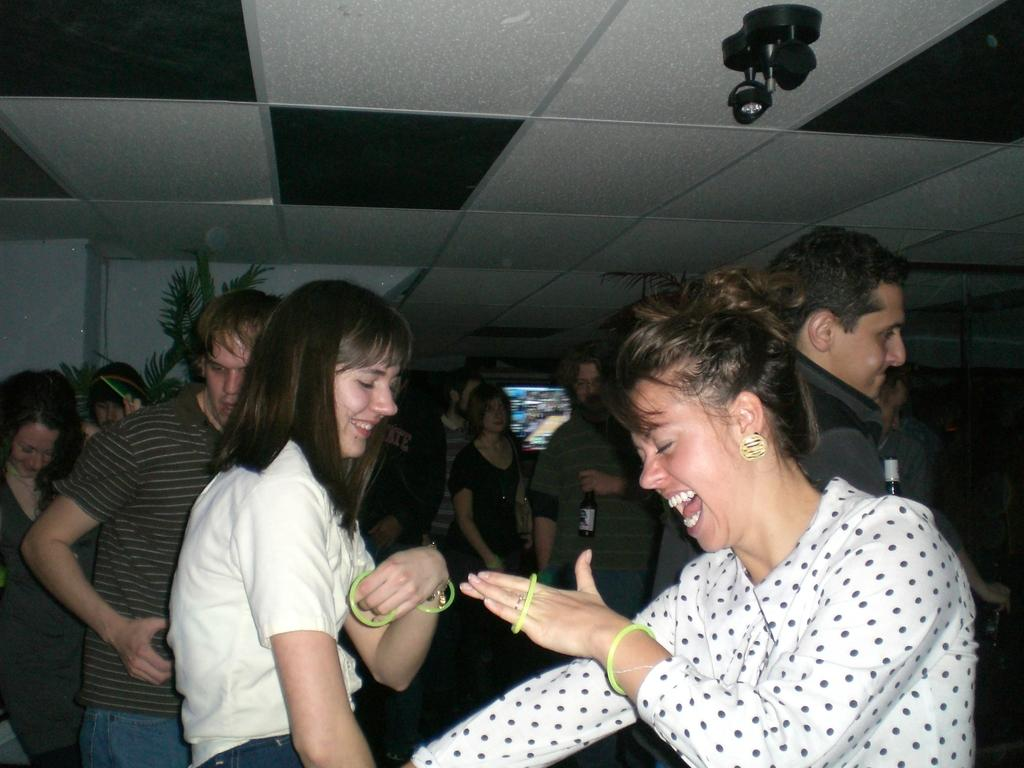How many people are standing and smiling in the image? There are two persons standing and smiling in the image. What is the general arrangement of people in the image? There is a group of people standing in the image. What type of plants can be seen in the image? There are house plants in the image. What is the nature of the screen in the image? There is a screen in the image, but its purpose or content is not specified. What can be seen at the top of the image? There are objects visible at the top of the image, but their nature is not specified. What type of rifle is visible in the image? There is no rifle present in the image. What is the purpose of the thing at the top of the image? There is no "thing" mentioned in the image, and therefore no purpose can be determined. 